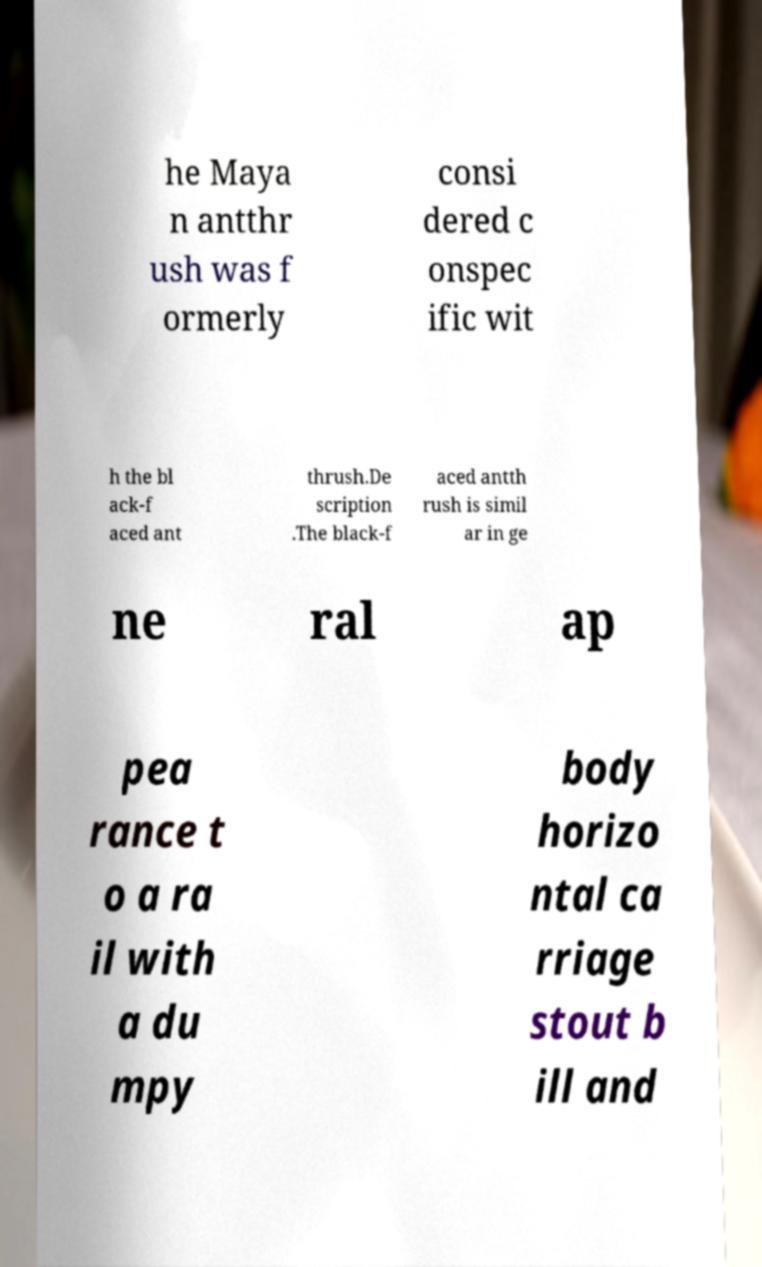There's text embedded in this image that I need extracted. Can you transcribe it verbatim? he Maya n antthr ush was f ormerly consi dered c onspec ific wit h the bl ack-f aced ant thrush.De scription .The black-f aced antth rush is simil ar in ge ne ral ap pea rance t o a ra il with a du mpy body horizo ntal ca rriage stout b ill and 